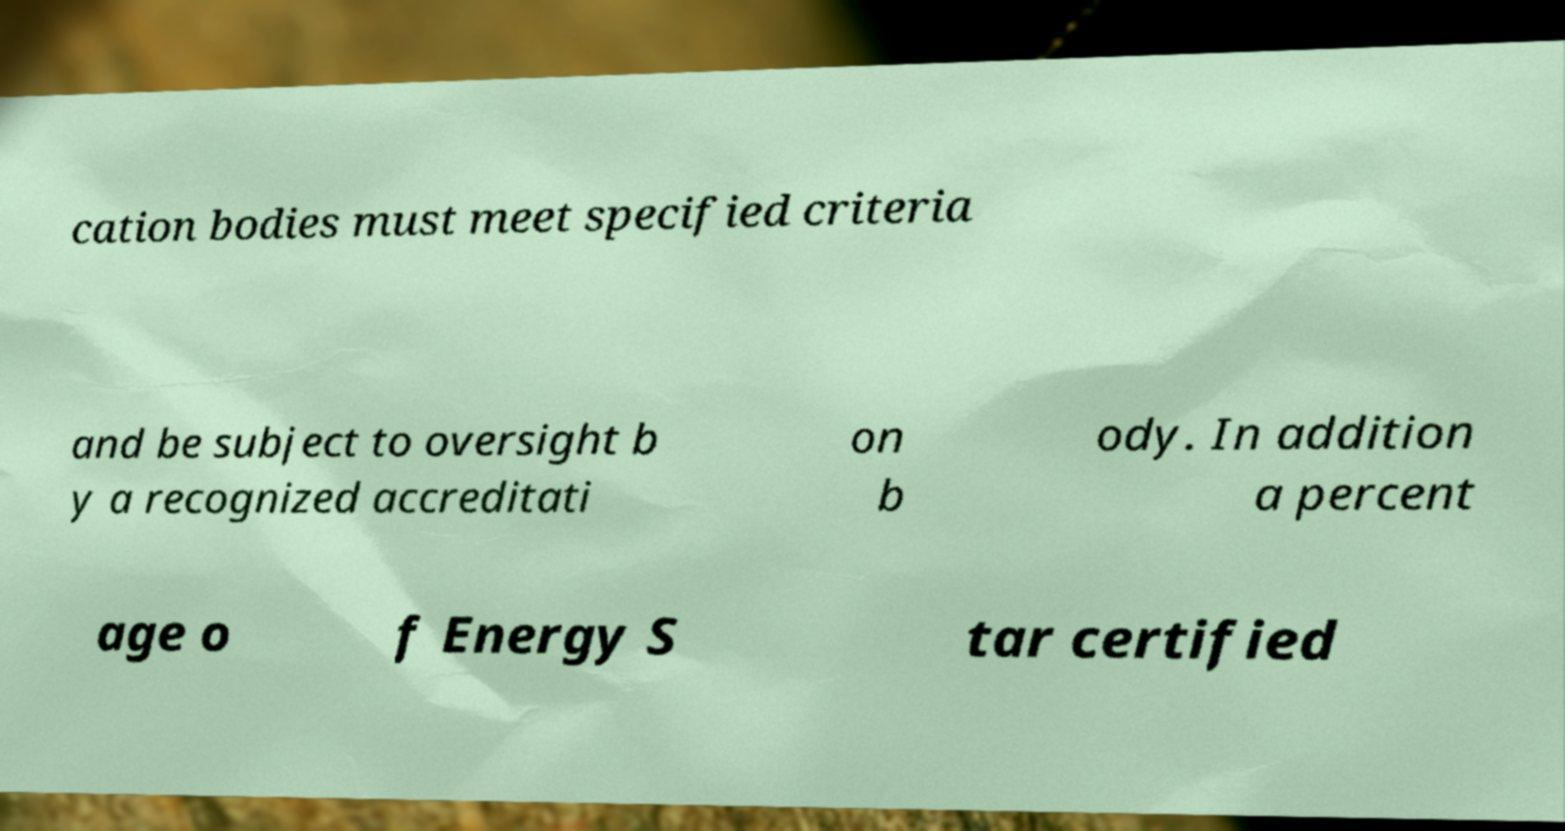Can you read and provide the text displayed in the image?This photo seems to have some interesting text. Can you extract and type it out for me? cation bodies must meet specified criteria and be subject to oversight b y a recognized accreditati on b ody. In addition a percent age o f Energy S tar certified 